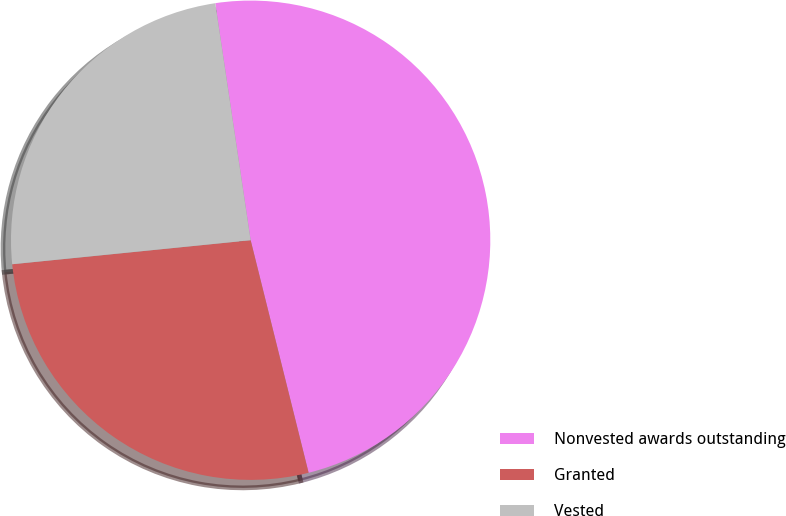Convert chart to OTSL. <chart><loc_0><loc_0><loc_500><loc_500><pie_chart><fcel>Nonvested awards outstanding<fcel>Granted<fcel>Vested<nl><fcel>48.47%<fcel>27.29%<fcel>24.24%<nl></chart> 